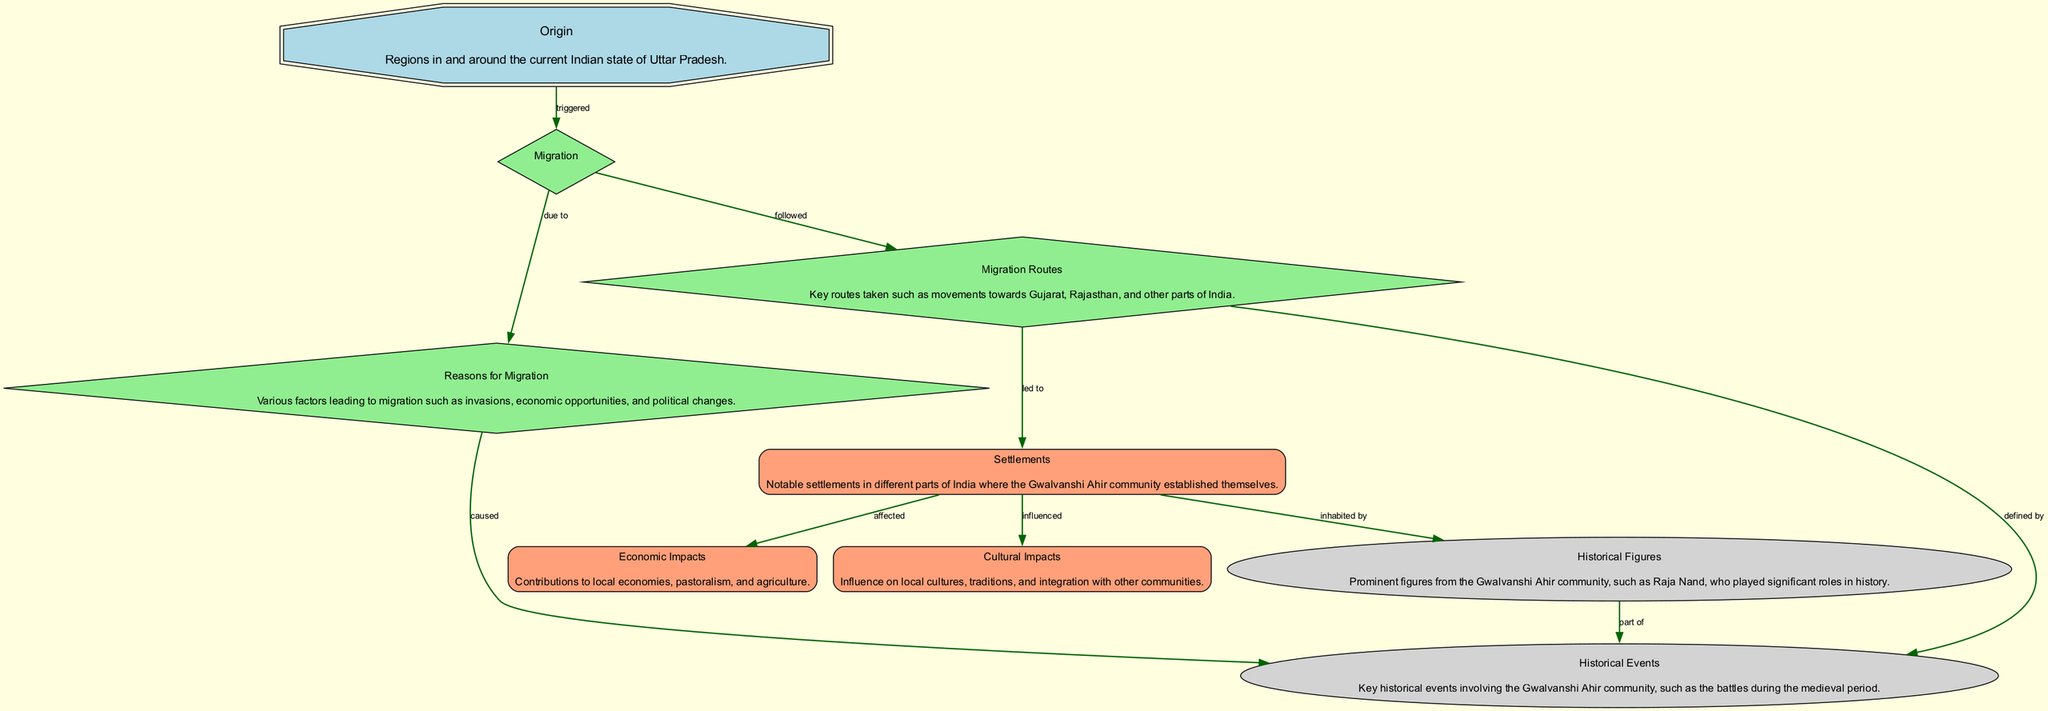What is the origin of the Gwalvanshi Ahir community? The diagram indicates that the origin of the Gwalvanshi Ahir community is "Regions in and around the current Indian state of Uttar Pradesh."
Answer: Regions in and around the current Indian state of Uttar Pradesh How many nodes are present in the diagram? By counting the nodes listed, there are a total of nine distinct nodes: Origin, Migration, Reasons for Migration, Migration Routes, Settlements, Economic Impacts, Cultural Impacts, Historical Figures, and Historical Events.
Answer: 9 What are the reasons for migration? The reasons for migration as mentioned in the diagram include "Various factors leading to migration such as invasions, economic opportunities, and political changes."
Answer: Various factors leading to migration such as invasions, economic opportunities, and political changes What relationship is depicted between "settlements" and "cultural impacts"? According to the diagram, the relationship is described with the label "influenced," which indicates that settlements had an influence on cultural impacts.
Answer: influenced What routes did the Gwalvanshi Ahir community follow during migration? The diagram lists key migration routes that were taken by the community, specifically stating "movements towards Gujarat, Rajasthan, and other parts of India."
Answer: movements towards Gujarat, Rajasthan, and other parts of India What is one key historical event linked to the Gwalvanshi Ahir community? The diagram connects historical events to the community, particularly highlighting "Key historical events involving the Gwalvanshi Ahir community, such as the battles during the medieval period."
Answer: Key historical events involving the Gwalvanshi Ahir community, such as the battles during the medieval period How are historical figures related to historical events in the diagram? The relationship is shown with the label "part of," indicating that historical figures from the Gwalvanshi Ahir community were involved in significant events.
Answer: part of Which component affected the economic impacts according to the diagram? The component mentioned that affected economic impacts is "settlements," demonstrating a direct relationship between where communities settled and their economic contributions.
Answer: settlements What is the significance of migration in the Gwalvanshi Ahir community's history? The diagram describes migration as a process that was "triggered" by their origin, indicating that it is a fundamental aspect of their historical narrative.
Answer: triggered 